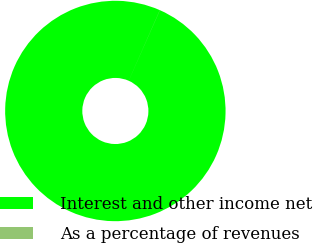Convert chart to OTSL. <chart><loc_0><loc_0><loc_500><loc_500><pie_chart><fcel>Interest and other income net<fcel>As a percentage of revenues<nl><fcel>99.99%<fcel>0.01%<nl></chart> 